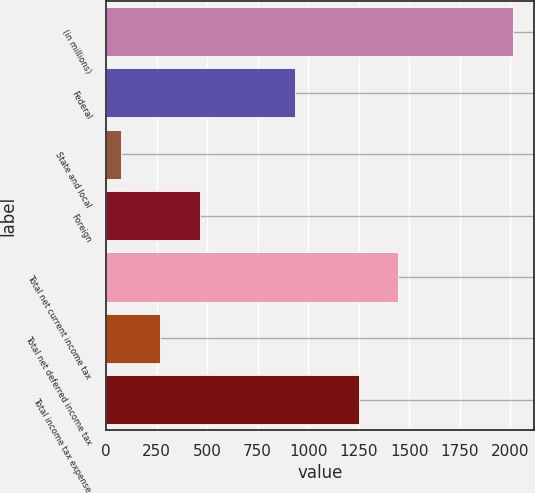Convert chart to OTSL. <chart><loc_0><loc_0><loc_500><loc_500><bar_chart><fcel>(in millions)<fcel>Federal<fcel>State and local<fcel>Foreign<fcel>Total net current income tax<fcel>Total net deferred income tax<fcel>Total income tax expense<nl><fcel>2015<fcel>937<fcel>74<fcel>462.2<fcel>1444.1<fcel>268.1<fcel>1250<nl></chart> 